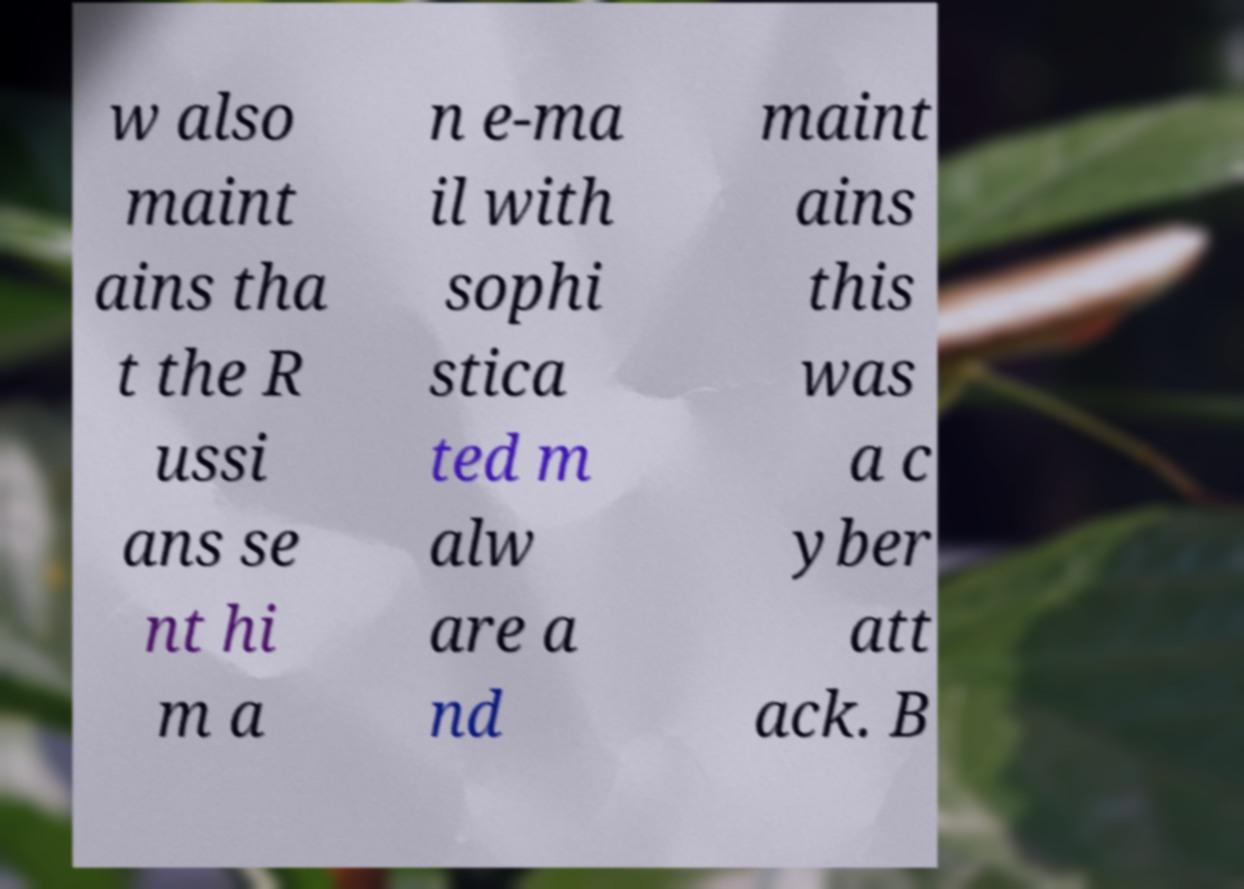I need the written content from this picture converted into text. Can you do that? w also maint ains tha t the R ussi ans se nt hi m a n e-ma il with sophi stica ted m alw are a nd maint ains this was a c yber att ack. B 